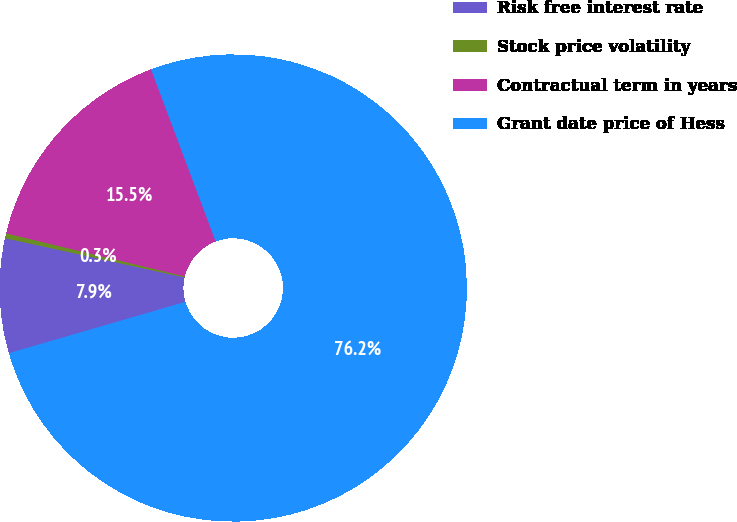Convert chart. <chart><loc_0><loc_0><loc_500><loc_500><pie_chart><fcel>Risk free interest rate<fcel>Stock price volatility<fcel>Contractual term in years<fcel>Grant date price of Hess<nl><fcel>7.93%<fcel>0.34%<fcel>15.52%<fcel>76.21%<nl></chart> 